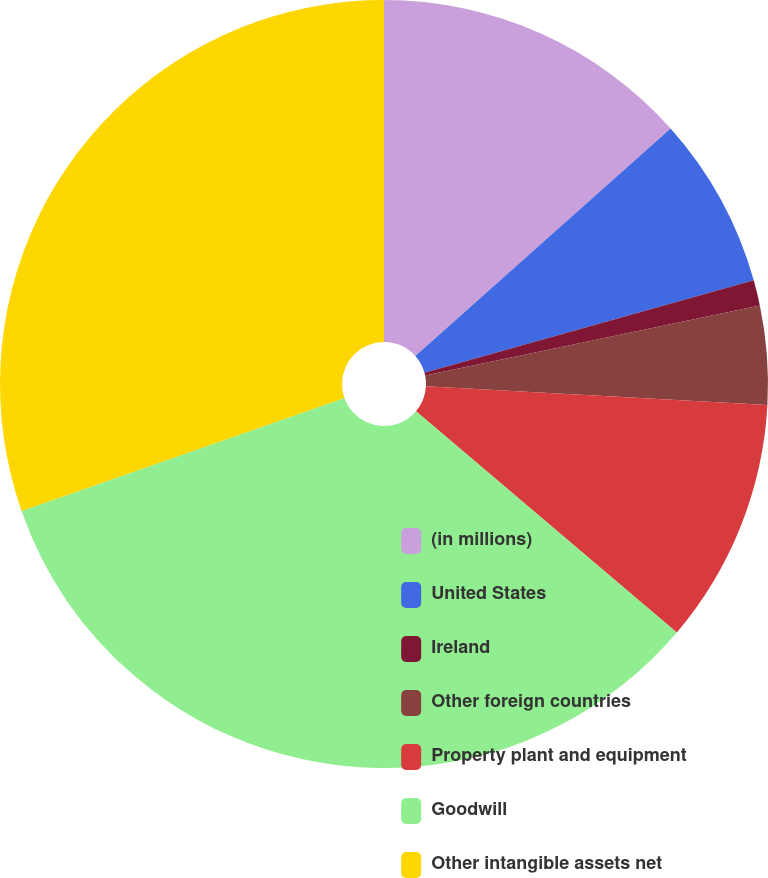Convert chart. <chart><loc_0><loc_0><loc_500><loc_500><pie_chart><fcel>(in millions)<fcel>United States<fcel>Ireland<fcel>Other foreign countries<fcel>Property plant and equipment<fcel>Goodwill<fcel>Other intangible assets net<nl><fcel>13.41%<fcel>7.24%<fcel>1.07%<fcel>4.15%<fcel>10.33%<fcel>33.44%<fcel>30.36%<nl></chart> 